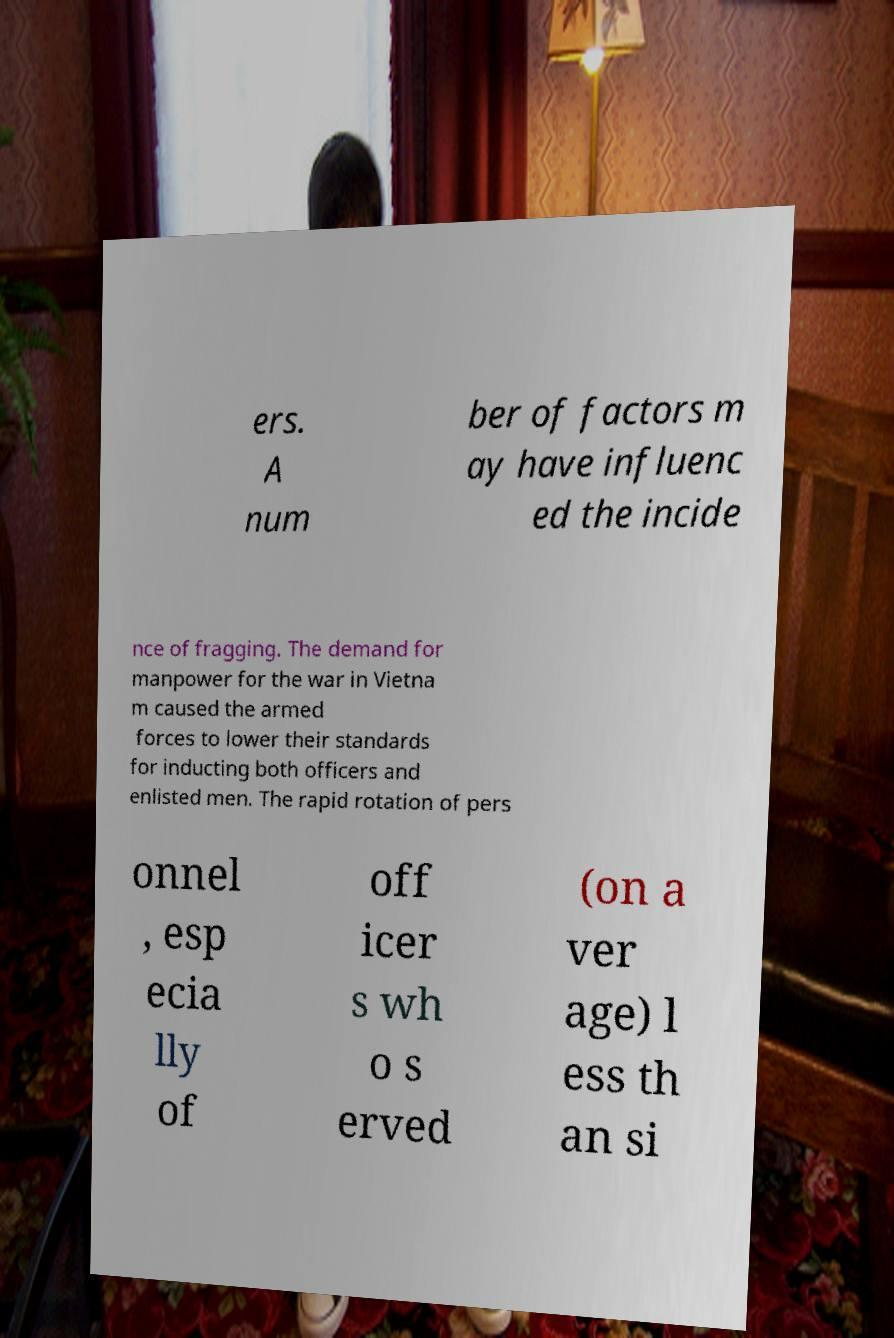I need the written content from this picture converted into text. Can you do that? ers. A num ber of factors m ay have influenc ed the incide nce of fragging. The demand for manpower for the war in Vietna m caused the armed forces to lower their standards for inducting both officers and enlisted men. The rapid rotation of pers onnel , esp ecia lly of off icer s wh o s erved (on a ver age) l ess th an si 